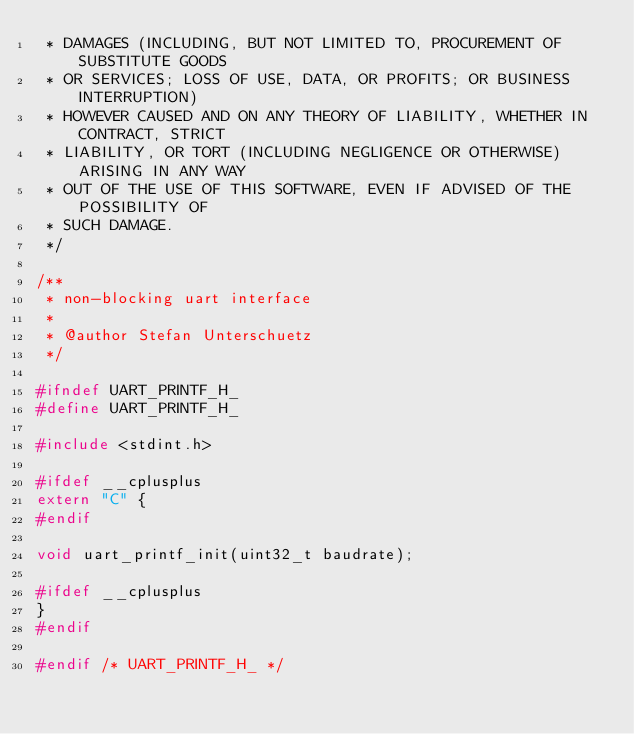<code> <loc_0><loc_0><loc_500><loc_500><_C_> * DAMAGES (INCLUDING, BUT NOT LIMITED TO, PROCUREMENT OF SUBSTITUTE GOODS
 * OR SERVICES; LOSS OF USE, DATA, OR PROFITS; OR BUSINESS INTERRUPTION)
 * HOWEVER CAUSED AND ON ANY THEORY OF LIABILITY, WHETHER IN CONTRACT, STRICT
 * LIABILITY, OR TORT (INCLUDING NEGLIGENCE OR OTHERWISE) ARISING IN ANY WAY
 * OUT OF THE USE OF THIS SOFTWARE, EVEN IF ADVISED OF THE POSSIBILITY OF
 * SUCH DAMAGE.
 */

/**
 * non-blocking uart interface
 *
 * @author Stefan Unterschuetz
 */

#ifndef UART_PRINTF_H_
#define UART_PRINTF_H_

#include <stdint.h>

#ifdef __cplusplus
extern "C" {
#endif

void uart_printf_init(uint32_t baudrate);

#ifdef __cplusplus
}
#endif

#endif /* UART_PRINTF_H_ */
</code> 